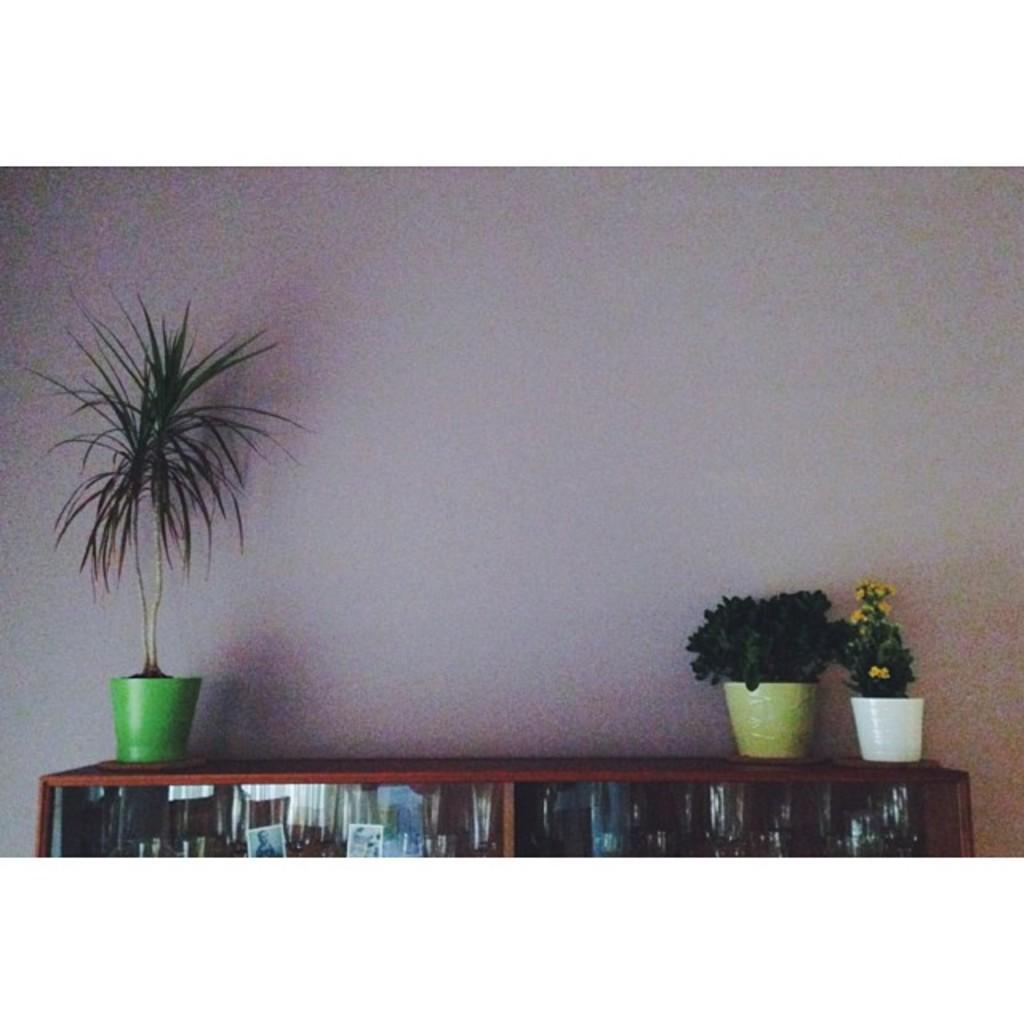Can you describe this image briefly? In this image we can see there is the cupboard and there are a few objects in it and there are potted plants and at the back there is the wall. 